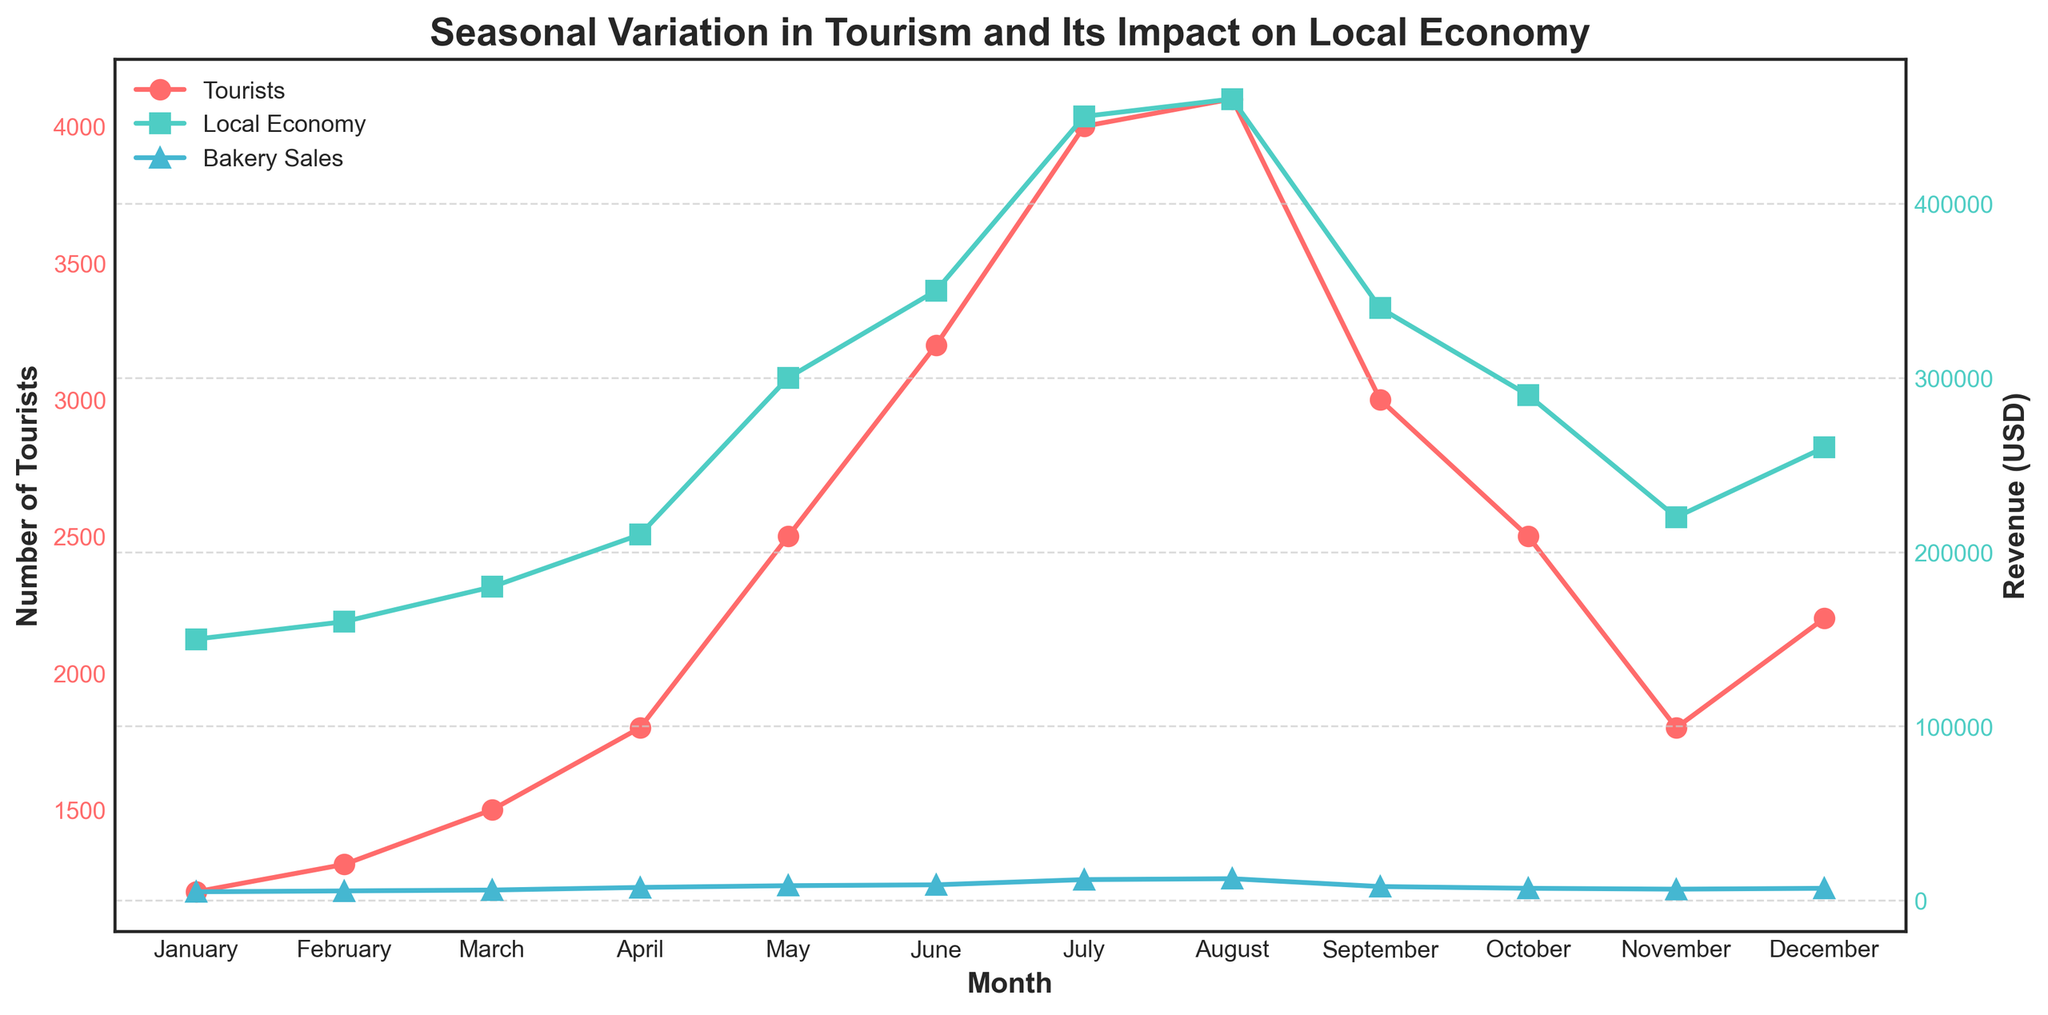What is the title of the figure? The title is usually displayed at the top of the figure. It gives a brief overview of what the figure is about.
Answer: Seasonal Variation in Tourism and Its Impact on Local Economy What color is used to represent 'Number of Tourists' in the plot? Colors help differentiate various data series. To identify the color representing 'Number of Tourists', you need to look at the line and its corresponding label in the legend.
Answer: Red How does the number of tourists change from May to June? To understand the change, look at the 'Number of Tourists' line from May to June and observe the difference in their values.
Answer: It increases Which month has the highest bakery sales? Look at the 'Bakery Sales' line and find the month corresponding to its peak value.
Answer: August How does the local economy revenue trend from January to December? Observe the 'Local Economy Revenue (USD)' line from the start to the end of the time series to understand its general trend.
Answer: It generally increases with some fluctuation In which months do the local economy revenue and bakery sales show the highest correlation? Compare the trends of 'Local Economy Revenue (USD)' and 'Bakery Sales (USD)' lines month by month to see where they move similarly.
Answer: July and August What is the difference in the number of tourists between the peak month and the month with the lowest number of tourists? Identify the months with the highest and lowest numbers of tourists, then calculate the difference. Peak (August): 4100, Lowest (January): 1200, Difference: 4100 - 1200 = 2900
Answer: 2900 How much did bakery sales increase from March to May? Find the bakery sales values for March and May, then subtract the March value from the May value. March: 6000, May: 8500, Increase: 8500 - 6000 = 2500
Answer: 2500 Is there a noticeable drop in the number of tourists after the peak month? Look at the 'Number of Tourists' line after the peak value. Check if there is a decline. The peak is in August (4100), and it drops to 3000 in September.
Answer: Yes By how much does bakery sales exceed local economy revenue in July? Find the values for bakery sales and local economy revenue in July and calculate the difference. Bakery sales (July): 12000, Local economy revenue (July): 450,000, Difference: 450000 - 12000 = 438000
Answer: 438000 